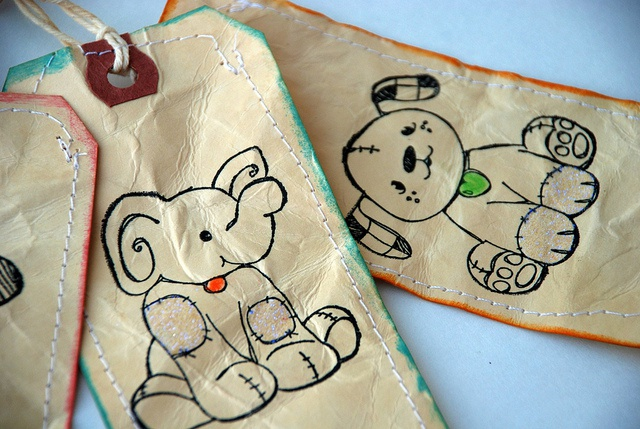Describe the objects in this image and their specific colors. I can see a dog in black and tan tones in this image. 